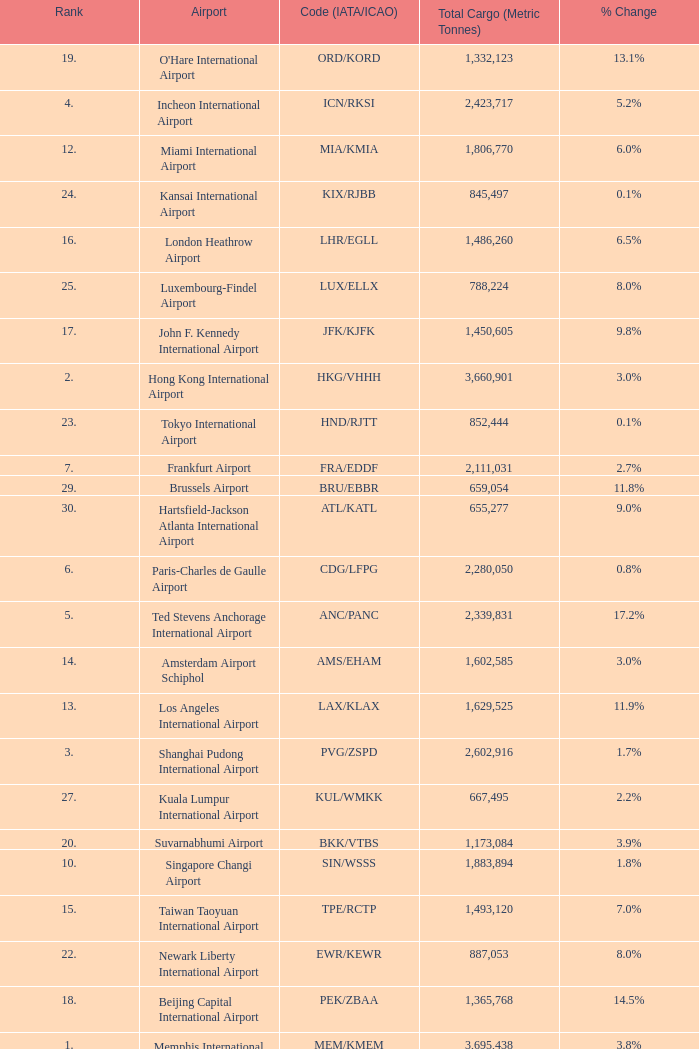Parse the table in full. {'header': ['Rank', 'Airport', 'Code (IATA/ICAO)', 'Total Cargo (Metric Tonnes)', '% Change'], 'rows': [['19.', "O'Hare International Airport", 'ORD/KORD', '1,332,123', '13.1%'], ['4.', 'Incheon International Airport', 'ICN/RKSI', '2,423,717', '5.2%'], ['12.', 'Miami International Airport', 'MIA/KMIA', '1,806,770', '6.0%'], ['24.', 'Kansai International Airport', 'KIX/RJBB', '845,497', '0.1%'], ['16.', 'London Heathrow Airport', 'LHR/EGLL', '1,486,260', '6.5%'], ['25.', 'Luxembourg-Findel Airport', 'LUX/ELLX', '788,224', '8.0%'], ['17.', 'John F. Kennedy International Airport', 'JFK/KJFK', '1,450,605', '9.8%'], ['2.', 'Hong Kong International Airport', 'HKG/VHHH', '3,660,901', '3.0%'], ['23.', 'Tokyo International Airport', 'HND/RJTT', '852,444', '0.1%'], ['7.', 'Frankfurt Airport', 'FRA/EDDF', '2,111,031', '2.7%'], ['29.', 'Brussels Airport', 'BRU/EBBR', '659,054', '11.8%'], ['30.', 'Hartsfield-Jackson Atlanta International Airport', 'ATL/KATL', '655,277', '9.0%'], ['6.', 'Paris-Charles de Gaulle Airport', 'CDG/LFPG', '2,280,050', '0.8%'], ['5.', 'Ted Stevens Anchorage International Airport', 'ANC/PANC', '2,339,831', '17.2%'], ['14.', 'Amsterdam Airport Schiphol', 'AMS/EHAM', '1,602,585', '3.0%'], ['13.', 'Los Angeles International Airport', 'LAX/KLAX', '1,629,525', '11.9%'], ['3.', 'Shanghai Pudong International Airport', 'PVG/ZSPD', '2,602,916', '1.7%'], ['27.', 'Kuala Lumpur International Airport', 'KUL/WMKK', '667,495', '2.2%'], ['20.', 'Suvarnabhumi Airport', 'BKK/VTBS', '1,173,084', '3.9%'], ['10.', 'Singapore Changi Airport', 'SIN/WSSS', '1,883,894', '1.8%'], ['15.', 'Taiwan Taoyuan International Airport', 'TPE/RCTP', '1,493,120', '7.0%'], ['22.', 'Newark Liberty International Airport', 'EWR/KEWR', '887,053', '8.0%'], ['18.', 'Beijing Capital International Airport', 'PEK/ZBAA', '1,365,768', '14.5%'], ['1.', 'Memphis International Airport', 'MEM/KMEM', '3,695,438', '3.8%'], ['11.', 'Dubai International Airport', 'DXB/OMDB', '1,824,992', '9.4%'], ['21.', 'Indianapolis International Airport', 'IND/KIND', '1,039,993', '5.6%'], ['28.', 'Dallas-Fort Worth International Airport', 'DFW/KDFW', '660,036', '8.7%'], ['8.', 'Narita International Airport', 'NRT/RJAA', '2,100,448', '6.8%'], ['9.', 'Louisville International Airport', 'SDF/KSDF', '1,974,276', '5.0%'], ['26.', 'Guangzhou Baiyun International Airport', 'CAN/ZGGG', '685,868', '1.3%']]} What is the code for rank 10? SIN/WSSS. 